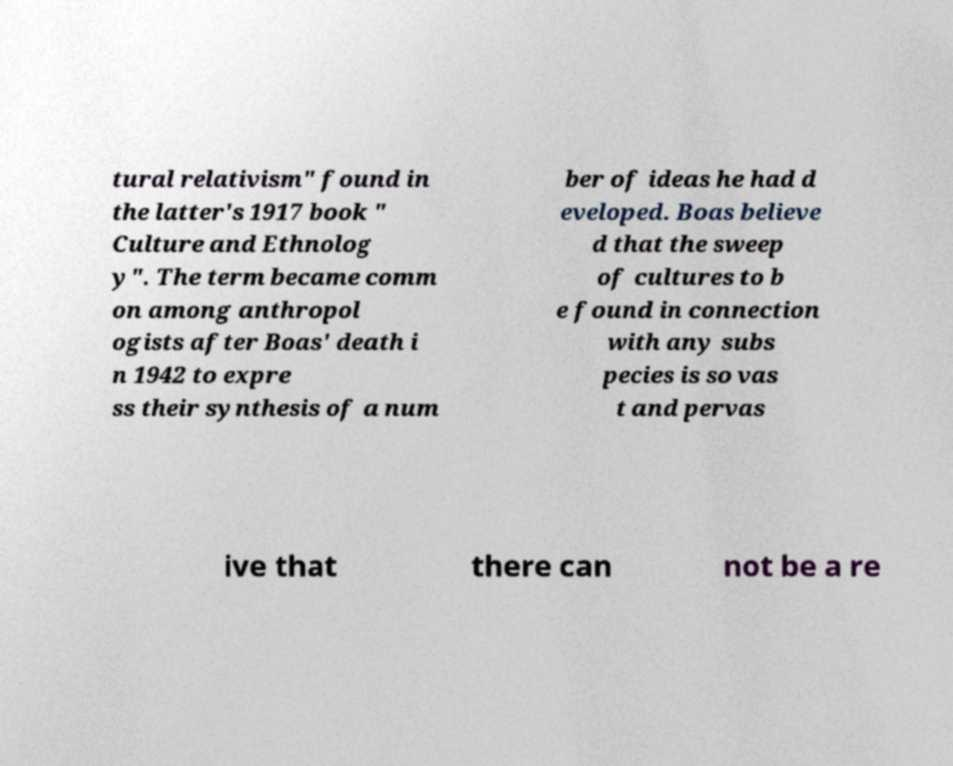There's text embedded in this image that I need extracted. Can you transcribe it verbatim? tural relativism" found in the latter's 1917 book " Culture and Ethnolog y". The term became comm on among anthropol ogists after Boas' death i n 1942 to expre ss their synthesis of a num ber of ideas he had d eveloped. Boas believe d that the sweep of cultures to b e found in connection with any subs pecies is so vas t and pervas ive that there can not be a re 